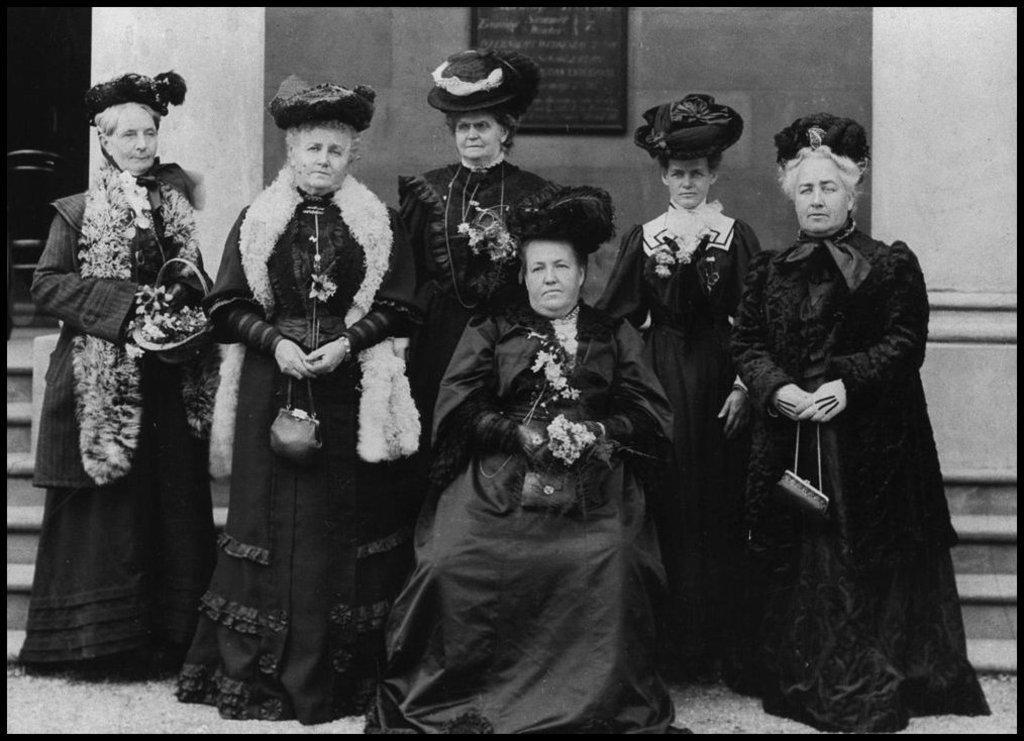In one or two sentences, can you explain what this image depicts? In this black and white picture we can see the woman is sitting and other five women are standing and looking at someone. 